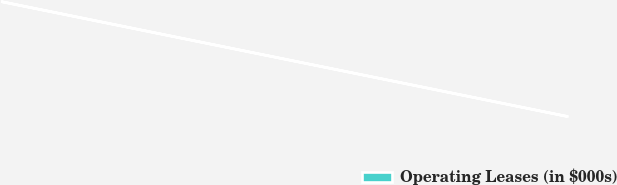Convert chart. <chart><loc_0><loc_0><loc_500><loc_500><pie_chart><fcel>Operating Leases (in $000s)<nl><fcel>100.0%<nl></chart> 